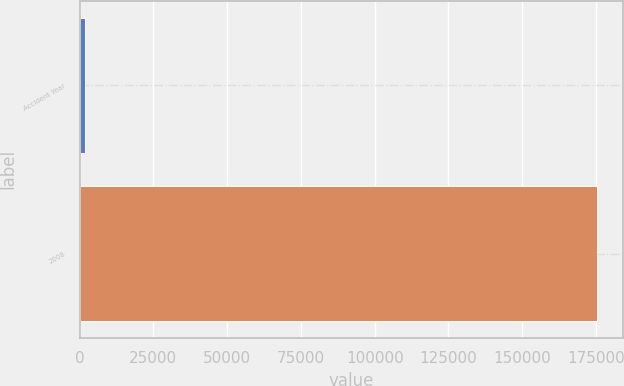<chart> <loc_0><loc_0><loc_500><loc_500><bar_chart><fcel>Accident Year<fcel>2008<nl><fcel>2008<fcel>175402<nl></chart> 